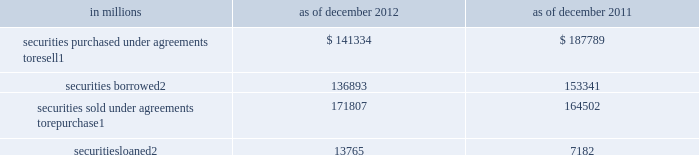Notes to consolidated financial statements note 9 .
Collateralized agreements and financings collateralized agreements are securities purchased under agreements to resell ( resale agreements or reverse repurchase agreements ) and securities borrowed .
Collateralized financings are securities sold under agreements to repurchase ( repurchase agreements ) , securities loaned and other secured financings .
The firm enters into these transactions in order to , among other things , facilitate client activities , invest excess cash , acquire securities to cover short positions and finance certain firm activities .
Collateralized agreements and financings are presented on a net-by-counterparty basis when a legal right of setoff exists .
Interest on collateralized agreements and collateralized financings is recognized over the life of the transaction and included in 201cinterest income 201d and 201cinterest expense , 201d respectively .
See note 23 for further information about interest income and interest expense .
The table below presents the carrying value of resale and repurchase agreements and securities borrowed and loaned transactions. .
In millions 2012 2011 securities purchased under agreements to resell 1 $ 141334 $ 187789 securities borrowed 2 136893 153341 securities sold under agreements to repurchase 1 171807 164502 securities loaned 2 13765 7182 1 .
Substantially all resale and repurchase agreements are carried at fair value under the fair value option .
See note 8 for further information about the valuation techniques and significant inputs used to determine fair value .
As of december 2012 and december 2011 , $ 38.40 billion and $ 47.62 billion of securities borrowed , and $ 1.56 billion and $ 107 million of securities loaned were at fair value , respectively .
Resale and repurchase agreements a resale agreement is a transaction in which the firm purchases financial instruments from a seller , typically in exchange for cash , and simultaneously enters into an agreement to resell the same or substantially the same financial instruments to the seller at a stated price plus accrued interest at a future date .
A repurchase agreement is a transaction in which the firm sells financial instruments to a buyer , typically in exchange for cash , and simultaneously enters into an agreement to repurchase the same or substantially the same financial instruments from the buyer at a stated price plus accrued interest at a future date .
The financial instruments purchased or sold in resale and repurchase agreements typically include u.s .
Government and federal agency , and investment-grade sovereign obligations .
The firm receives financial instruments purchased under resale agreements , makes delivery of financial instruments sold under repurchase agreements , monitors the market value of these financial instruments on a daily basis , and delivers or obtains additional collateral due to changes in the market value of the financial instruments , as appropriate .
For resale agreements , the firm typically requires delivery of collateral with a fair value approximately equal to the carrying value of the relevant assets in the consolidated statements of financial condition .
Even though repurchase and resale agreements involve the legal transfer of ownership of financial instruments , they are accounted for as financing arrangements because they require the financial instruments to be repurchased or resold at the maturity of the agreement .
However , 201crepos to maturity 201d are accounted for as sales .
A repo to maturity is a transaction in which the firm transfers a security under an agreement to repurchase the security where the maturity date of the repurchase agreement matches the maturity date of the underlying security .
Therefore , the firm effectively no longer has a repurchase obligation and has relinquished control over the underlying security and , accordingly , accounts for the transaction as a sale .
The firm had no repos to maturity outstanding as of december 2012 or december 2011 .
152 goldman sachs 2012 annual report .
What was the change in millions of securities purchased under agreements to resell between 2011 and 2012? 
Computations: (141334 - 187789)
Answer: -46455.0. 